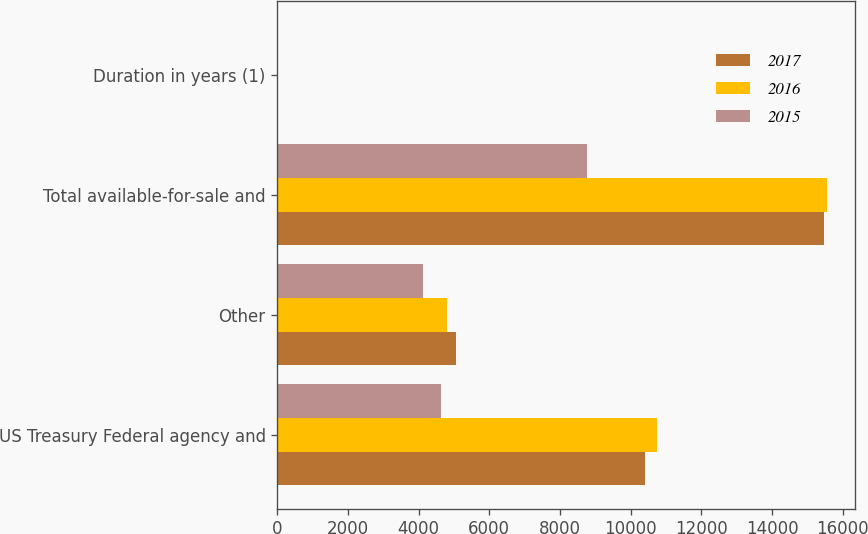Convert chart to OTSL. <chart><loc_0><loc_0><loc_500><loc_500><stacked_bar_chart><ecel><fcel>US Treasury Federal agency and<fcel>Other<fcel>Total available-for-sale and<fcel>Duration in years (1)<nl><fcel>2017<fcel>10413<fcel>5056<fcel>15469<fcel>4.9<nl><fcel>2016<fcel>10752<fcel>4811<fcel>15563<fcel>4.7<nl><fcel>2015<fcel>4643<fcel>4132<fcel>8775<fcel>5.2<nl></chart> 